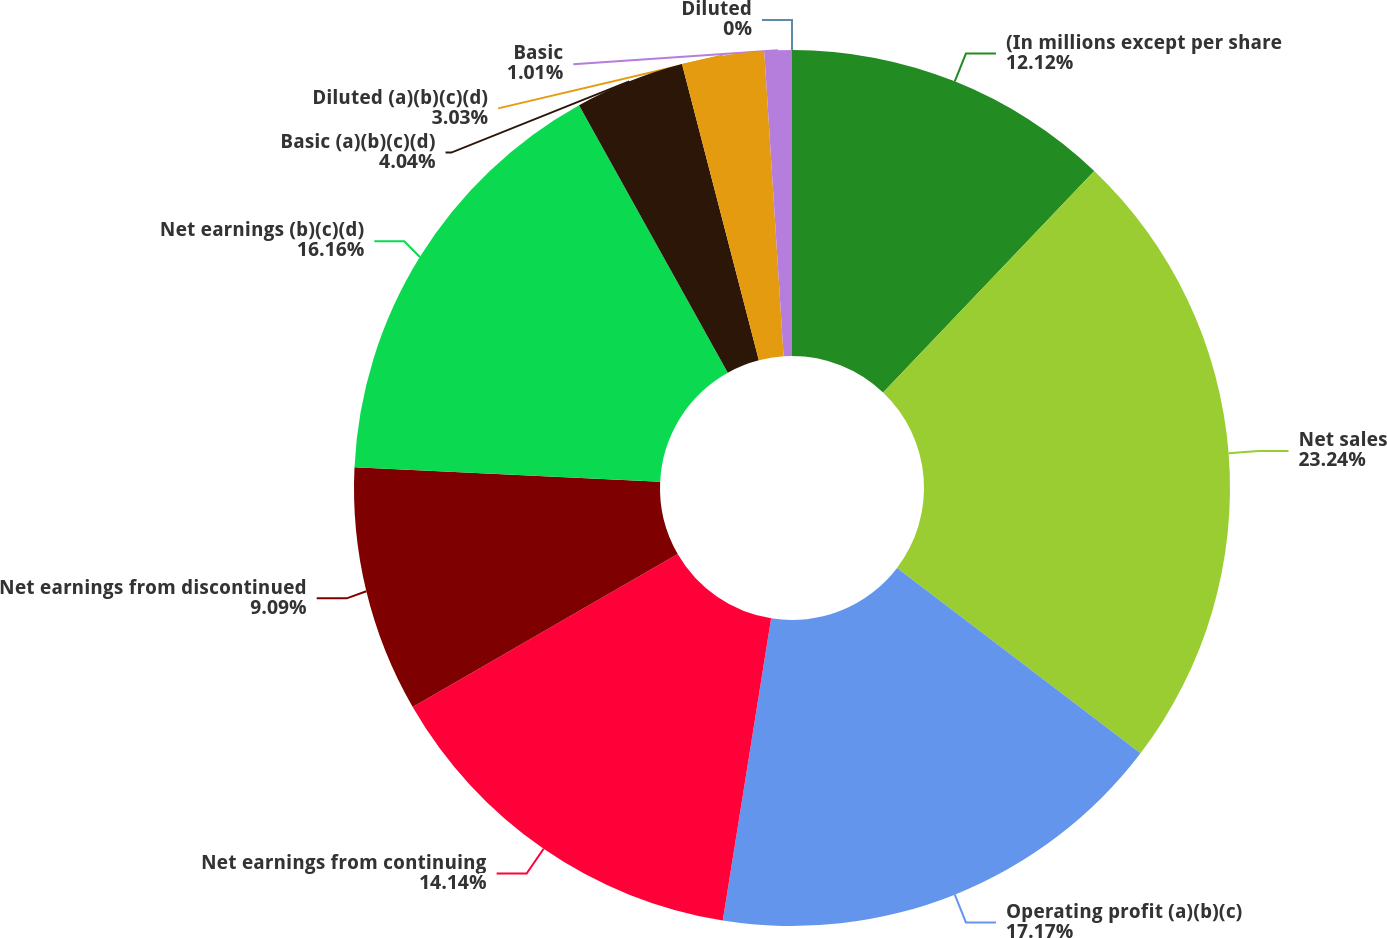<chart> <loc_0><loc_0><loc_500><loc_500><pie_chart><fcel>(In millions except per share<fcel>Net sales<fcel>Operating profit (a)(b)(c)<fcel>Net earnings from continuing<fcel>Net earnings from discontinued<fcel>Net earnings (b)(c)(d)<fcel>Basic (a)(b)(c)(d)<fcel>Diluted (a)(b)(c)(d)<fcel>Basic<fcel>Diluted<nl><fcel>12.12%<fcel>23.23%<fcel>17.17%<fcel>14.14%<fcel>9.09%<fcel>16.16%<fcel>4.04%<fcel>3.03%<fcel>1.01%<fcel>0.0%<nl></chart> 